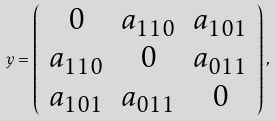Convert formula to latex. <formula><loc_0><loc_0><loc_500><loc_500>y = \left ( \begin{array} { c c c } 0 & a _ { 1 1 0 } & a _ { 1 0 1 } \\ a _ { 1 1 0 } & 0 & a _ { 0 1 1 } \\ a _ { 1 0 1 } & a _ { 0 1 1 } & 0 \end{array} \right ) ,</formula> 